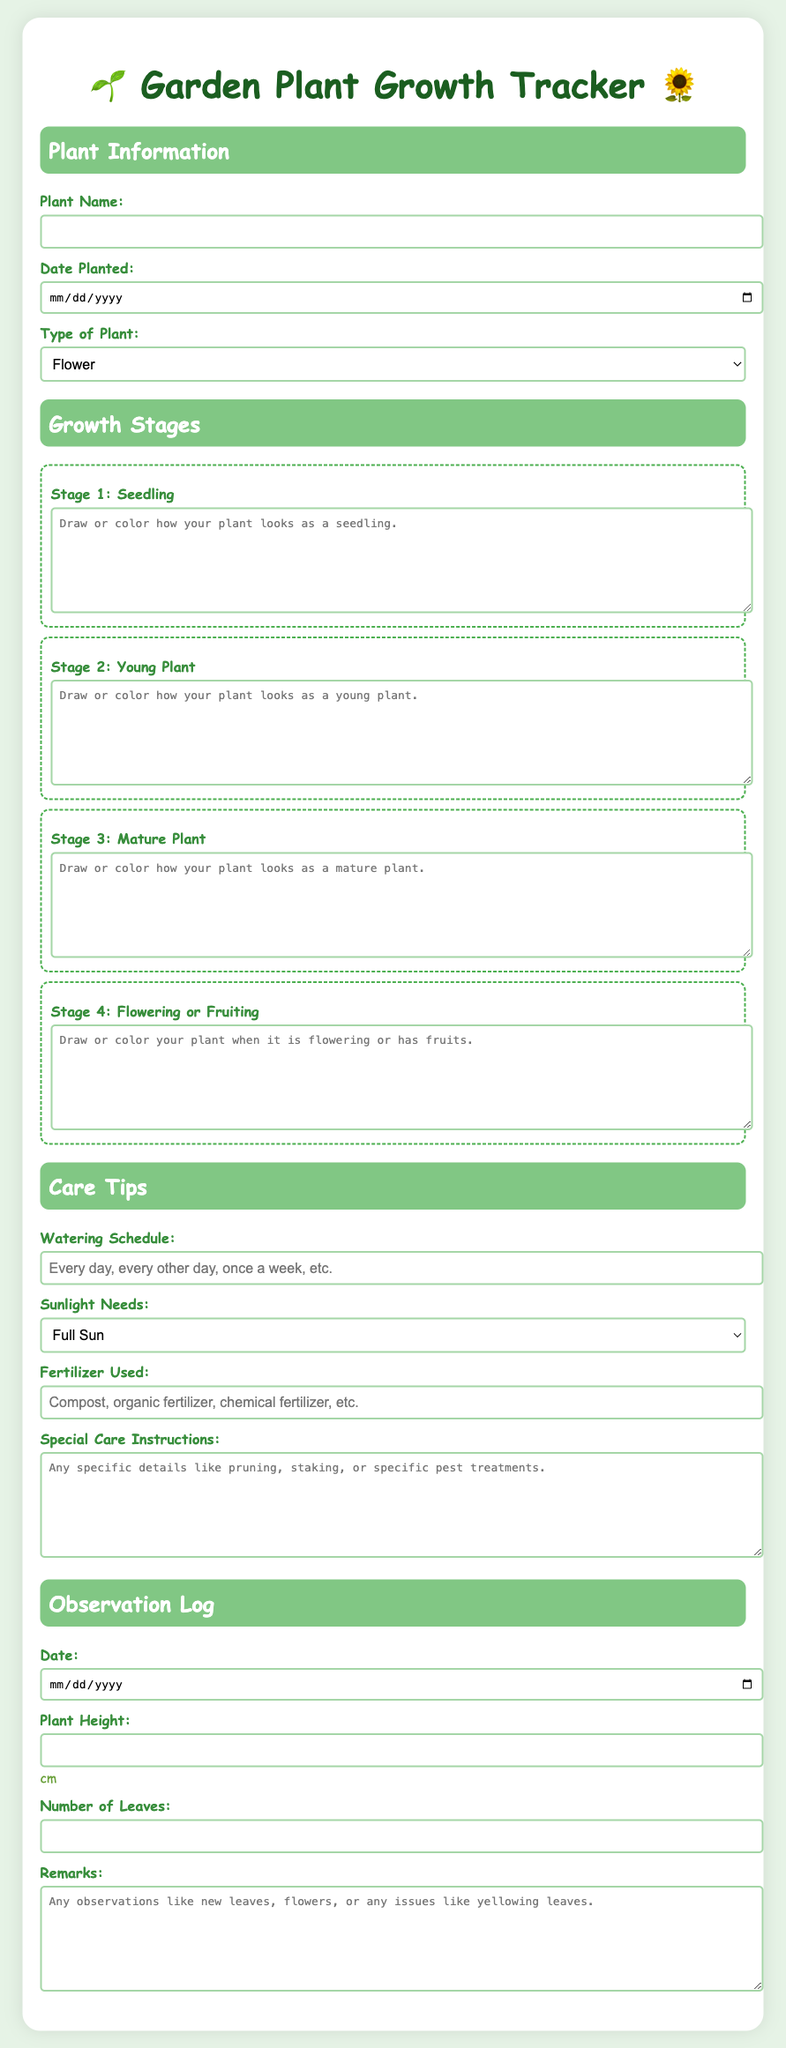What is the title of the document? The title is displayed prominently at the top of the document, indicating the purpose of the content.
Answer: Garden Plant Growth Tracker What types of plants can be selected? The document includes a dropdown menu with various options for plant types.
Answer: Flower, Vegetable, Herb, Tree, Shrub How many growth stages are there? The document outlines distinct stages of plant growth and includes sections for each stage.
Answer: 4 What is the purpose of the "Observation Log" section? This section is intended for recording plant growth details and observations over time.
Answer: To record plant growth details and observations What can be noted under "Special Care Instructions"? This section is a textarea where specific details about plant care can be mentioned.
Answer: Any specific details like pruning, staking, or specific pest treatments Which stage allows for drawing or coloring? Each growth stage section has space for illustrations, especially for the initial stages.
Answer: All stages allow for drawing or coloring 